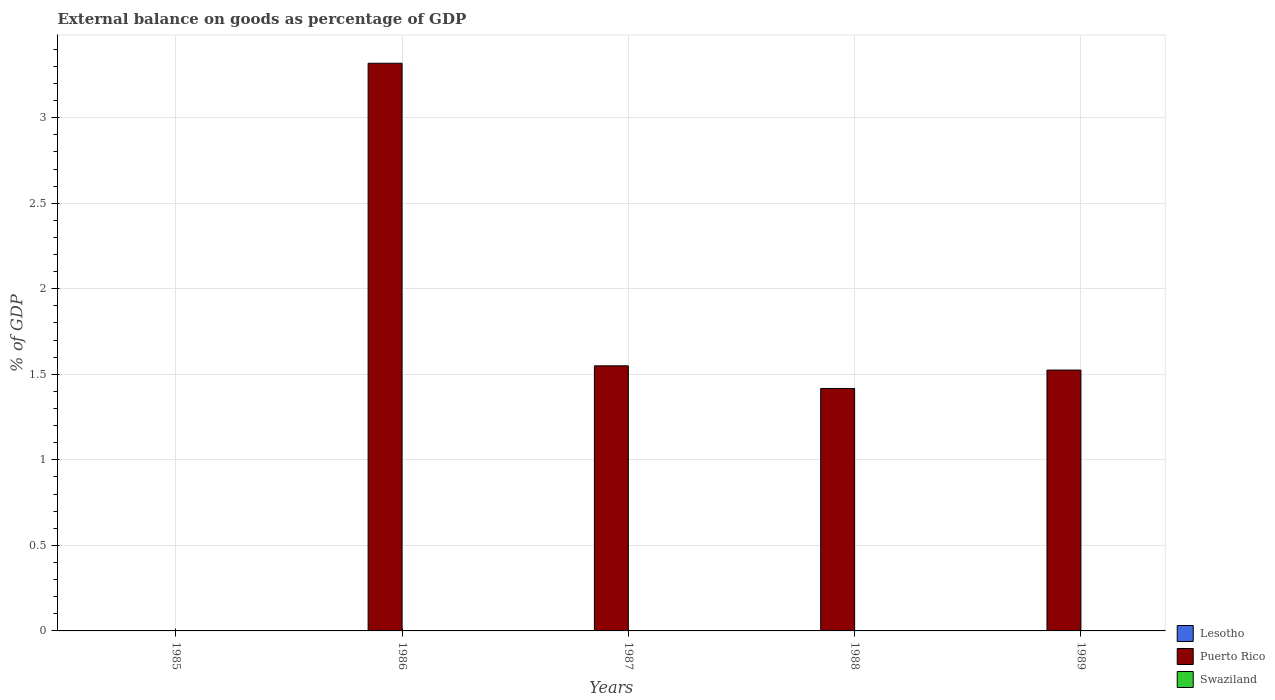Are the number of bars on each tick of the X-axis equal?
Your answer should be compact. No. How many bars are there on the 2nd tick from the left?
Offer a very short reply. 1. How many bars are there on the 2nd tick from the right?
Your answer should be very brief. 1. What is the label of the 2nd group of bars from the left?
Provide a short and direct response. 1986. In how many cases, is the number of bars for a given year not equal to the number of legend labels?
Give a very brief answer. 5. What is the external balance on goods as percentage of GDP in Lesotho in 1987?
Ensure brevity in your answer.  0. Across all years, what is the maximum external balance on goods as percentage of GDP in Puerto Rico?
Keep it short and to the point. 3.32. Across all years, what is the minimum external balance on goods as percentage of GDP in Puerto Rico?
Your answer should be very brief. 0. What is the total external balance on goods as percentage of GDP in Puerto Rico in the graph?
Make the answer very short. 7.81. What is the difference between the external balance on goods as percentage of GDP in Puerto Rico in 1986 and that in 1987?
Your response must be concise. 1.77. What is the difference between the external balance on goods as percentage of GDP in Swaziland in 1986 and the external balance on goods as percentage of GDP in Puerto Rico in 1989?
Provide a succinct answer. -1.52. What is the average external balance on goods as percentage of GDP in Puerto Rico per year?
Provide a short and direct response. 1.56. What is the ratio of the external balance on goods as percentage of GDP in Puerto Rico in 1986 to that in 1989?
Offer a very short reply. 2.18. Is the external balance on goods as percentage of GDP in Puerto Rico in 1986 less than that in 1988?
Provide a short and direct response. No. What is the difference between the highest and the second highest external balance on goods as percentage of GDP in Puerto Rico?
Give a very brief answer. 1.77. What is the difference between the highest and the lowest external balance on goods as percentage of GDP in Puerto Rico?
Your answer should be very brief. 3.32. Is the sum of the external balance on goods as percentage of GDP in Puerto Rico in 1987 and 1989 greater than the maximum external balance on goods as percentage of GDP in Swaziland across all years?
Give a very brief answer. Yes. Are the values on the major ticks of Y-axis written in scientific E-notation?
Ensure brevity in your answer.  No. Does the graph contain any zero values?
Keep it short and to the point. Yes. Where does the legend appear in the graph?
Provide a succinct answer. Bottom right. How many legend labels are there?
Give a very brief answer. 3. How are the legend labels stacked?
Provide a succinct answer. Vertical. What is the title of the graph?
Provide a short and direct response. External balance on goods as percentage of GDP. What is the label or title of the X-axis?
Your answer should be compact. Years. What is the label or title of the Y-axis?
Give a very brief answer. % of GDP. What is the % of GDP in Swaziland in 1985?
Keep it short and to the point. 0. What is the % of GDP of Lesotho in 1986?
Give a very brief answer. 0. What is the % of GDP in Puerto Rico in 1986?
Provide a short and direct response. 3.32. What is the % of GDP in Swaziland in 1986?
Make the answer very short. 0. What is the % of GDP in Lesotho in 1987?
Make the answer very short. 0. What is the % of GDP of Puerto Rico in 1987?
Your answer should be very brief. 1.55. What is the % of GDP of Swaziland in 1987?
Provide a short and direct response. 0. What is the % of GDP in Lesotho in 1988?
Ensure brevity in your answer.  0. What is the % of GDP in Puerto Rico in 1988?
Keep it short and to the point. 1.42. What is the % of GDP of Lesotho in 1989?
Your answer should be very brief. 0. What is the % of GDP of Puerto Rico in 1989?
Make the answer very short. 1.52. Across all years, what is the maximum % of GDP of Puerto Rico?
Offer a terse response. 3.32. Across all years, what is the minimum % of GDP of Puerto Rico?
Your response must be concise. 0. What is the total % of GDP of Puerto Rico in the graph?
Make the answer very short. 7.81. What is the difference between the % of GDP of Puerto Rico in 1986 and that in 1987?
Keep it short and to the point. 1.77. What is the difference between the % of GDP of Puerto Rico in 1986 and that in 1988?
Provide a succinct answer. 1.9. What is the difference between the % of GDP in Puerto Rico in 1986 and that in 1989?
Provide a short and direct response. 1.79. What is the difference between the % of GDP in Puerto Rico in 1987 and that in 1988?
Offer a very short reply. 0.13. What is the difference between the % of GDP in Puerto Rico in 1987 and that in 1989?
Your answer should be compact. 0.02. What is the difference between the % of GDP of Puerto Rico in 1988 and that in 1989?
Keep it short and to the point. -0.11. What is the average % of GDP of Puerto Rico per year?
Your response must be concise. 1.56. What is the average % of GDP of Swaziland per year?
Give a very brief answer. 0. What is the ratio of the % of GDP of Puerto Rico in 1986 to that in 1987?
Provide a succinct answer. 2.14. What is the ratio of the % of GDP of Puerto Rico in 1986 to that in 1988?
Make the answer very short. 2.34. What is the ratio of the % of GDP in Puerto Rico in 1986 to that in 1989?
Offer a very short reply. 2.18. What is the ratio of the % of GDP in Puerto Rico in 1987 to that in 1988?
Your answer should be very brief. 1.09. What is the ratio of the % of GDP of Puerto Rico in 1987 to that in 1989?
Ensure brevity in your answer.  1.02. What is the ratio of the % of GDP in Puerto Rico in 1988 to that in 1989?
Provide a short and direct response. 0.93. What is the difference between the highest and the second highest % of GDP of Puerto Rico?
Your answer should be very brief. 1.77. What is the difference between the highest and the lowest % of GDP in Puerto Rico?
Give a very brief answer. 3.32. 